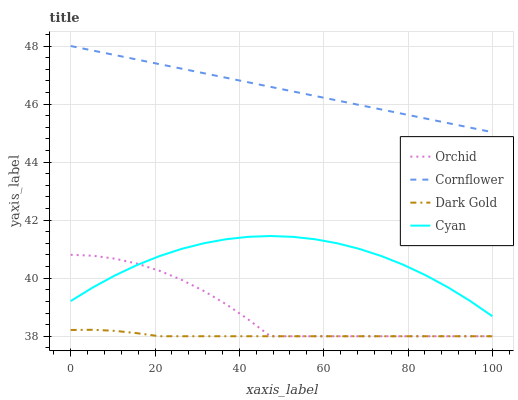Does Cyan have the minimum area under the curve?
Answer yes or no. No. Does Cyan have the maximum area under the curve?
Answer yes or no. No. Is Cyan the smoothest?
Answer yes or no. No. Is Cyan the roughest?
Answer yes or no. No. Does Cyan have the lowest value?
Answer yes or no. No. Does Cyan have the highest value?
Answer yes or no. No. Is Orchid less than Cornflower?
Answer yes or no. Yes. Is Cornflower greater than Dark Gold?
Answer yes or no. Yes. Does Orchid intersect Cornflower?
Answer yes or no. No. 